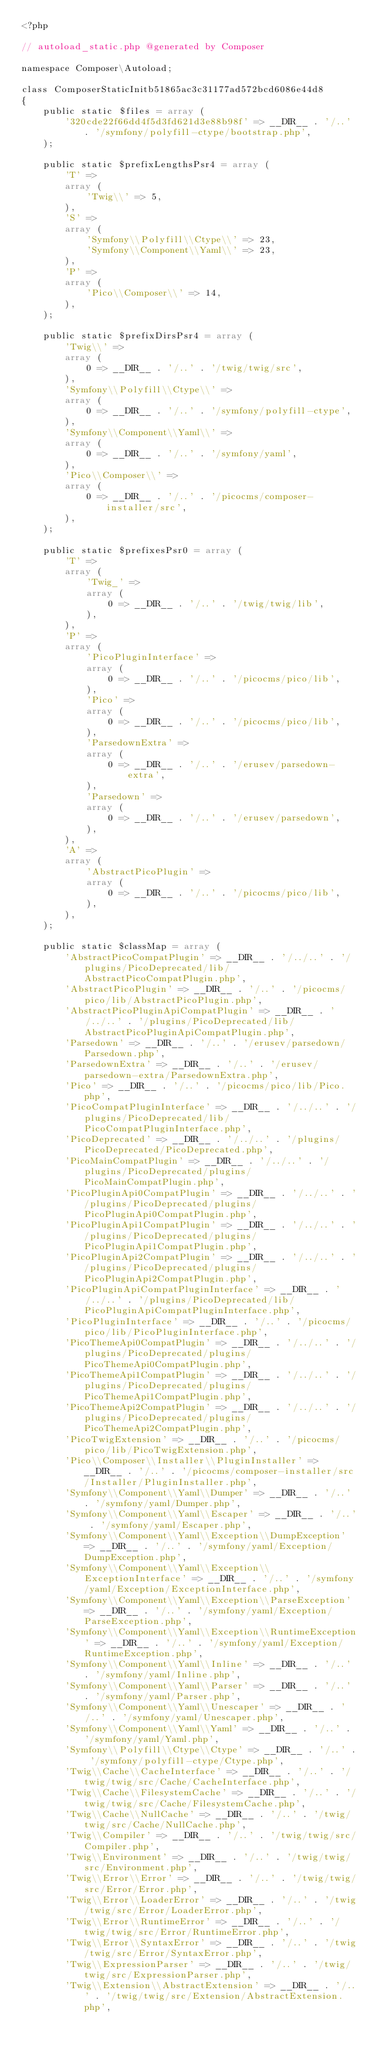Convert code to text. <code><loc_0><loc_0><loc_500><loc_500><_PHP_><?php

// autoload_static.php @generated by Composer

namespace Composer\Autoload;

class ComposerStaticInitb51865ac3c31177ad572bcd6086e44d8
{
    public static $files = array (
        '320cde22f66dd4f5d3fd621d3e88b98f' => __DIR__ . '/..' . '/symfony/polyfill-ctype/bootstrap.php',
    );

    public static $prefixLengthsPsr4 = array (
        'T' => 
        array (
            'Twig\\' => 5,
        ),
        'S' => 
        array (
            'Symfony\\Polyfill\\Ctype\\' => 23,
            'Symfony\\Component\\Yaml\\' => 23,
        ),
        'P' => 
        array (
            'Pico\\Composer\\' => 14,
        ),
    );

    public static $prefixDirsPsr4 = array (
        'Twig\\' => 
        array (
            0 => __DIR__ . '/..' . '/twig/twig/src',
        ),
        'Symfony\\Polyfill\\Ctype\\' => 
        array (
            0 => __DIR__ . '/..' . '/symfony/polyfill-ctype',
        ),
        'Symfony\\Component\\Yaml\\' => 
        array (
            0 => __DIR__ . '/..' . '/symfony/yaml',
        ),
        'Pico\\Composer\\' => 
        array (
            0 => __DIR__ . '/..' . '/picocms/composer-installer/src',
        ),
    );

    public static $prefixesPsr0 = array (
        'T' => 
        array (
            'Twig_' => 
            array (
                0 => __DIR__ . '/..' . '/twig/twig/lib',
            ),
        ),
        'P' => 
        array (
            'PicoPluginInterface' => 
            array (
                0 => __DIR__ . '/..' . '/picocms/pico/lib',
            ),
            'Pico' => 
            array (
                0 => __DIR__ . '/..' . '/picocms/pico/lib',
            ),
            'ParsedownExtra' => 
            array (
                0 => __DIR__ . '/..' . '/erusev/parsedown-extra',
            ),
            'Parsedown' => 
            array (
                0 => __DIR__ . '/..' . '/erusev/parsedown',
            ),
        ),
        'A' => 
        array (
            'AbstractPicoPlugin' => 
            array (
                0 => __DIR__ . '/..' . '/picocms/pico/lib',
            ),
        ),
    );

    public static $classMap = array (
        'AbstractPicoCompatPlugin' => __DIR__ . '/../..' . '/plugins/PicoDeprecated/lib/AbstractPicoCompatPlugin.php',
        'AbstractPicoPlugin' => __DIR__ . '/..' . '/picocms/pico/lib/AbstractPicoPlugin.php',
        'AbstractPicoPluginApiCompatPlugin' => __DIR__ . '/../..' . '/plugins/PicoDeprecated/lib/AbstractPicoPluginApiCompatPlugin.php',
        'Parsedown' => __DIR__ . '/..' . '/erusev/parsedown/Parsedown.php',
        'ParsedownExtra' => __DIR__ . '/..' . '/erusev/parsedown-extra/ParsedownExtra.php',
        'Pico' => __DIR__ . '/..' . '/picocms/pico/lib/Pico.php',
        'PicoCompatPluginInterface' => __DIR__ . '/../..' . '/plugins/PicoDeprecated/lib/PicoCompatPluginInterface.php',
        'PicoDeprecated' => __DIR__ . '/../..' . '/plugins/PicoDeprecated/PicoDeprecated.php',
        'PicoMainCompatPlugin' => __DIR__ . '/../..' . '/plugins/PicoDeprecated/plugins/PicoMainCompatPlugin.php',
        'PicoPluginApi0CompatPlugin' => __DIR__ . '/../..' . '/plugins/PicoDeprecated/plugins/PicoPluginApi0CompatPlugin.php',
        'PicoPluginApi1CompatPlugin' => __DIR__ . '/../..' . '/plugins/PicoDeprecated/plugins/PicoPluginApi1CompatPlugin.php',
        'PicoPluginApi2CompatPlugin' => __DIR__ . '/../..' . '/plugins/PicoDeprecated/plugins/PicoPluginApi2CompatPlugin.php',
        'PicoPluginApiCompatPluginInterface' => __DIR__ . '/../..' . '/plugins/PicoDeprecated/lib/PicoPluginApiCompatPluginInterface.php',
        'PicoPluginInterface' => __DIR__ . '/..' . '/picocms/pico/lib/PicoPluginInterface.php',
        'PicoThemeApi0CompatPlugin' => __DIR__ . '/../..' . '/plugins/PicoDeprecated/plugins/PicoThemeApi0CompatPlugin.php',
        'PicoThemeApi1CompatPlugin' => __DIR__ . '/../..' . '/plugins/PicoDeprecated/plugins/PicoThemeApi1CompatPlugin.php',
        'PicoThemeApi2CompatPlugin' => __DIR__ . '/../..' . '/plugins/PicoDeprecated/plugins/PicoThemeApi2CompatPlugin.php',
        'PicoTwigExtension' => __DIR__ . '/..' . '/picocms/pico/lib/PicoTwigExtension.php',
        'Pico\\Composer\\Installer\\PluginInstaller' => __DIR__ . '/..' . '/picocms/composer-installer/src/Installer/PluginInstaller.php',
        'Symfony\\Component\\Yaml\\Dumper' => __DIR__ . '/..' . '/symfony/yaml/Dumper.php',
        'Symfony\\Component\\Yaml\\Escaper' => __DIR__ . '/..' . '/symfony/yaml/Escaper.php',
        'Symfony\\Component\\Yaml\\Exception\\DumpException' => __DIR__ . '/..' . '/symfony/yaml/Exception/DumpException.php',
        'Symfony\\Component\\Yaml\\Exception\\ExceptionInterface' => __DIR__ . '/..' . '/symfony/yaml/Exception/ExceptionInterface.php',
        'Symfony\\Component\\Yaml\\Exception\\ParseException' => __DIR__ . '/..' . '/symfony/yaml/Exception/ParseException.php',
        'Symfony\\Component\\Yaml\\Exception\\RuntimeException' => __DIR__ . '/..' . '/symfony/yaml/Exception/RuntimeException.php',
        'Symfony\\Component\\Yaml\\Inline' => __DIR__ . '/..' . '/symfony/yaml/Inline.php',
        'Symfony\\Component\\Yaml\\Parser' => __DIR__ . '/..' . '/symfony/yaml/Parser.php',
        'Symfony\\Component\\Yaml\\Unescaper' => __DIR__ . '/..' . '/symfony/yaml/Unescaper.php',
        'Symfony\\Component\\Yaml\\Yaml' => __DIR__ . '/..' . '/symfony/yaml/Yaml.php',
        'Symfony\\Polyfill\\Ctype\\Ctype' => __DIR__ . '/..' . '/symfony/polyfill-ctype/Ctype.php',
        'Twig\\Cache\\CacheInterface' => __DIR__ . '/..' . '/twig/twig/src/Cache/CacheInterface.php',
        'Twig\\Cache\\FilesystemCache' => __DIR__ . '/..' . '/twig/twig/src/Cache/FilesystemCache.php',
        'Twig\\Cache\\NullCache' => __DIR__ . '/..' . '/twig/twig/src/Cache/NullCache.php',
        'Twig\\Compiler' => __DIR__ . '/..' . '/twig/twig/src/Compiler.php',
        'Twig\\Environment' => __DIR__ . '/..' . '/twig/twig/src/Environment.php',
        'Twig\\Error\\Error' => __DIR__ . '/..' . '/twig/twig/src/Error/Error.php',
        'Twig\\Error\\LoaderError' => __DIR__ . '/..' . '/twig/twig/src/Error/LoaderError.php',
        'Twig\\Error\\RuntimeError' => __DIR__ . '/..' . '/twig/twig/src/Error/RuntimeError.php',
        'Twig\\Error\\SyntaxError' => __DIR__ . '/..' . '/twig/twig/src/Error/SyntaxError.php',
        'Twig\\ExpressionParser' => __DIR__ . '/..' . '/twig/twig/src/ExpressionParser.php',
        'Twig\\Extension\\AbstractExtension' => __DIR__ . '/..' . '/twig/twig/src/Extension/AbstractExtension.php',</code> 